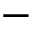<formula> <loc_0><loc_0><loc_500><loc_500>{ - }</formula> 